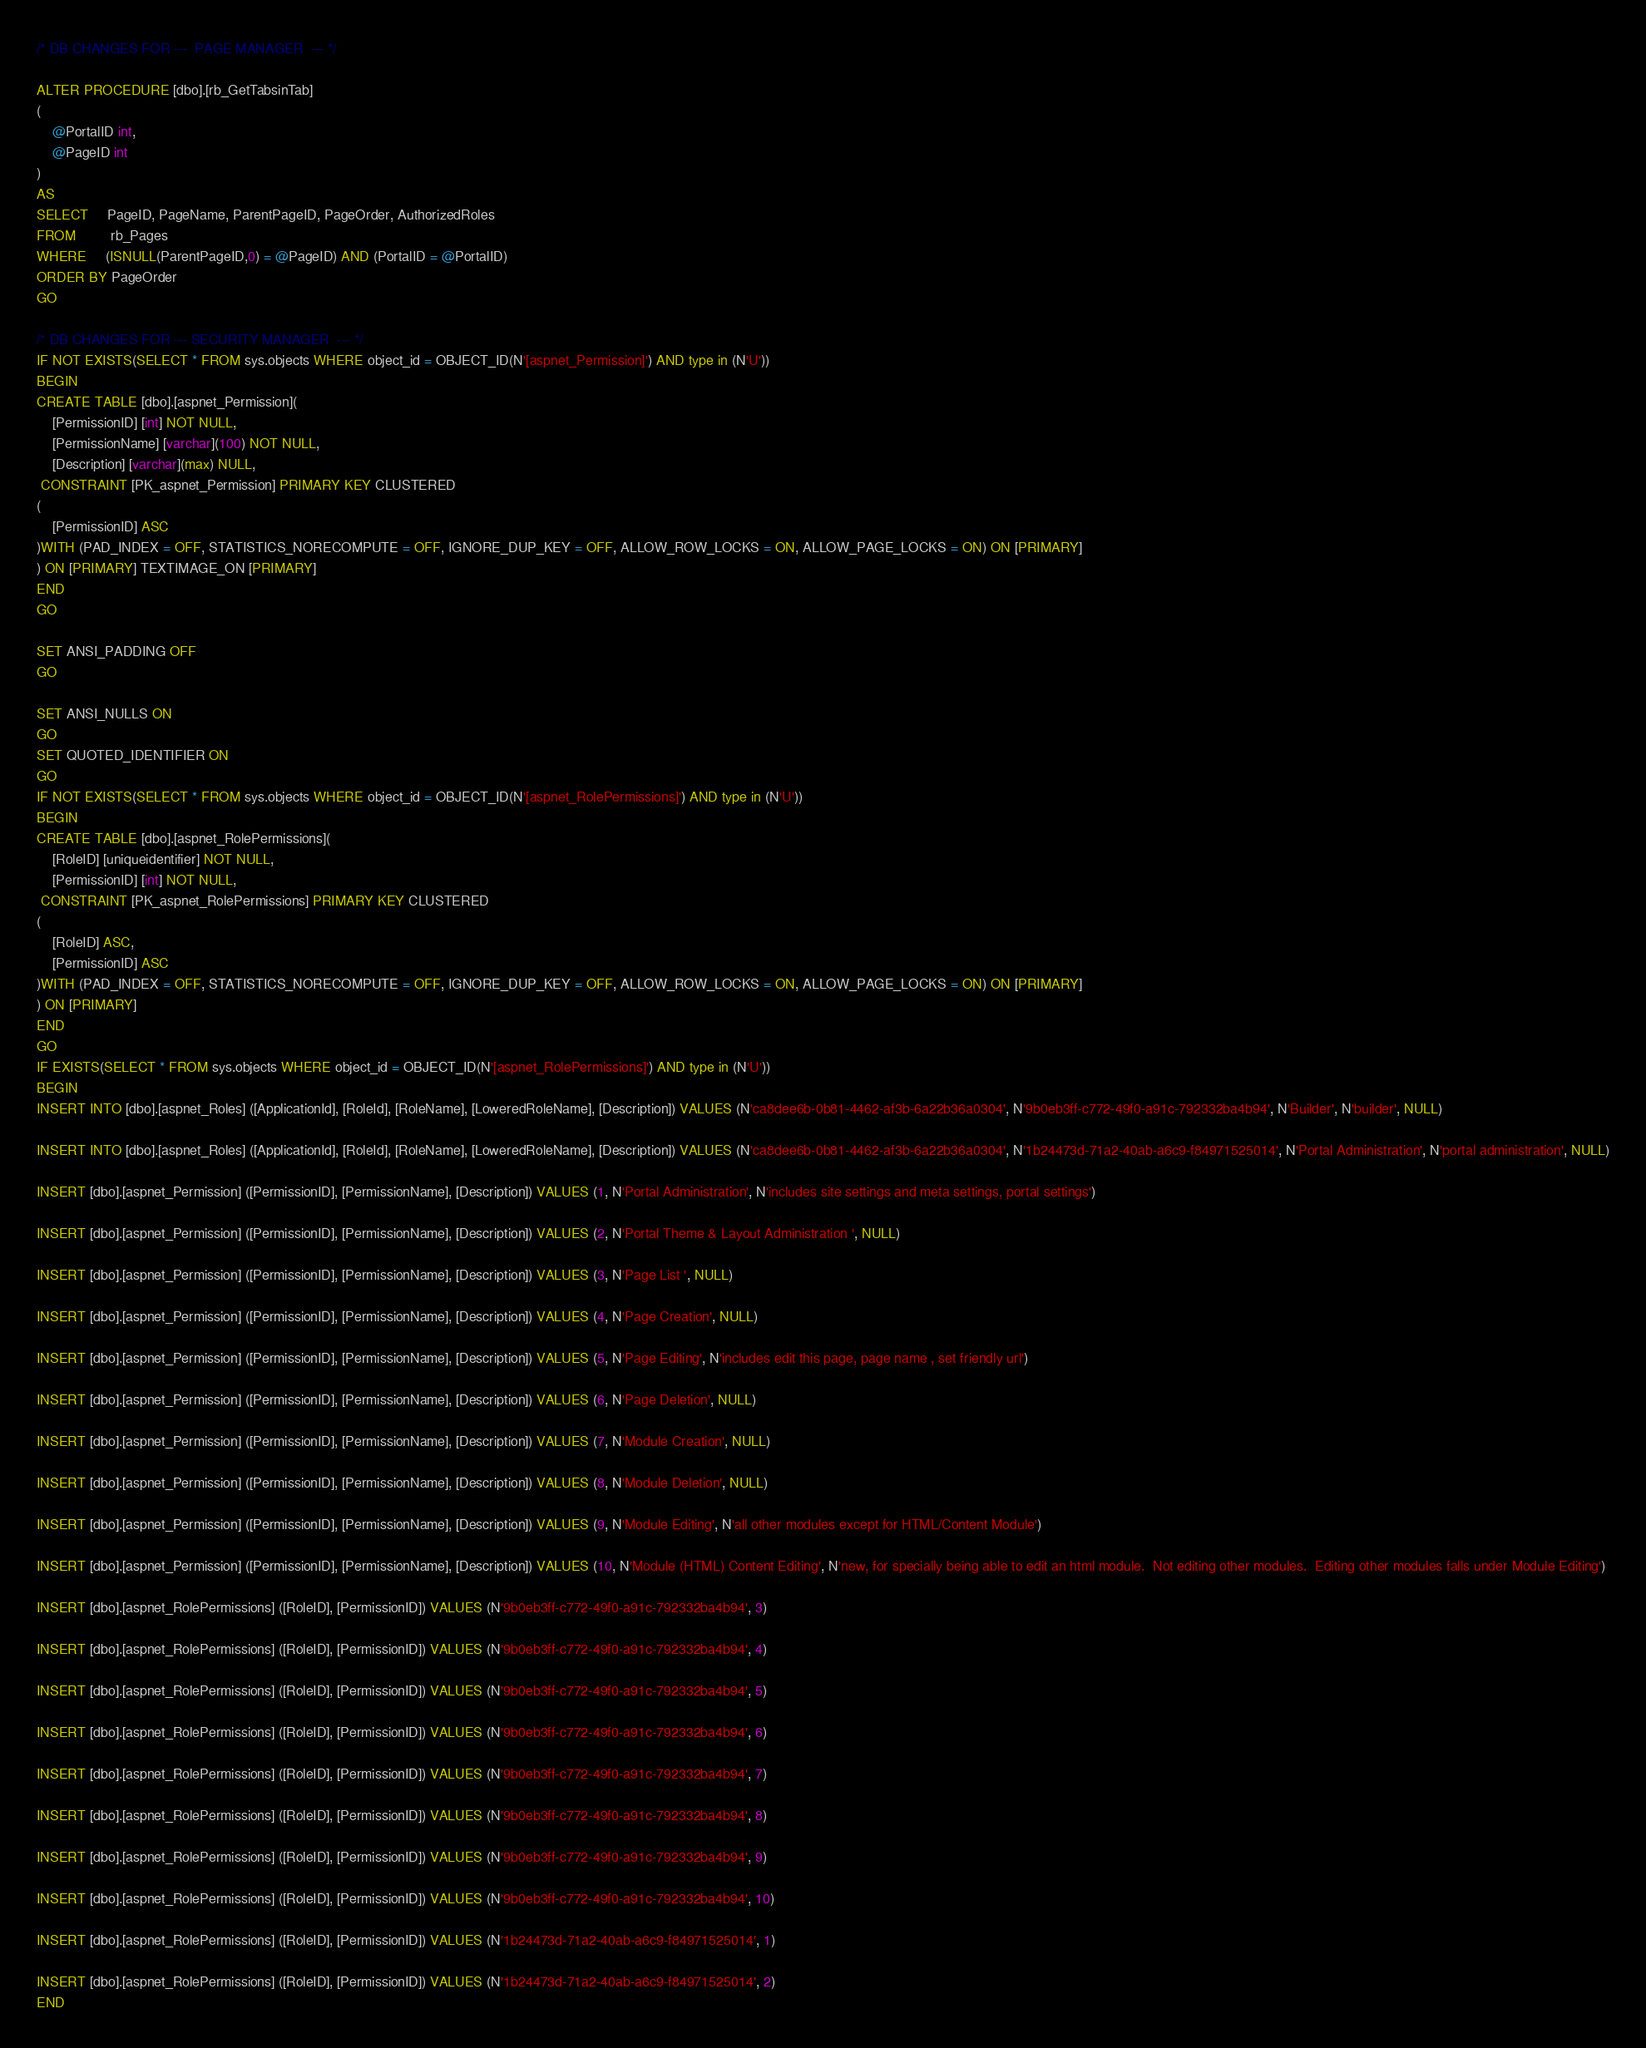Convert code to text. <code><loc_0><loc_0><loc_500><loc_500><_SQL_>/* DB CHANGES FOR ---  PAGE MANAGER  --- */

ALTER PROCEDURE [dbo].[rb_GetTabsinTab]
(
	@PortalID int,
	@PageID int
)
AS
SELECT     PageID, PageName, ParentPageID, PageOrder, AuthorizedRoles
FROM         rb_Pages
WHERE     (ISNULL(ParentPageID,0) = @PageID) AND (PortalID = @PortalID)
ORDER BY PageOrder
GO

/* DB CHANGES FOR --- SECURITY MANAGER  --- */
IF NOT EXISTS(SELECT * FROM sys.objects WHERE object_id = OBJECT_ID(N'[aspnet_Permission]') AND type in (N'U'))
BEGIN
CREATE TABLE [dbo].[aspnet_Permission](
	[PermissionID] [int] NOT NULL,
	[PermissionName] [varchar](100) NOT NULL,
	[Description] [varchar](max) NULL,
 CONSTRAINT [PK_aspnet_Permission] PRIMARY KEY CLUSTERED 
(
	[PermissionID] ASC
)WITH (PAD_INDEX = OFF, STATISTICS_NORECOMPUTE = OFF, IGNORE_DUP_KEY = OFF, ALLOW_ROW_LOCKS = ON, ALLOW_PAGE_LOCKS = ON) ON [PRIMARY]
) ON [PRIMARY] TEXTIMAGE_ON [PRIMARY]
END
GO

SET ANSI_PADDING OFF
GO

SET ANSI_NULLS ON
GO
SET QUOTED_IDENTIFIER ON
GO
IF NOT EXISTS(SELECT * FROM sys.objects WHERE object_id = OBJECT_ID(N'[aspnet_RolePermissions]') AND type in (N'U'))
BEGIN
CREATE TABLE [dbo].[aspnet_RolePermissions](
	[RoleID] [uniqueidentifier] NOT NULL,
	[PermissionID] [int] NOT NULL,
 CONSTRAINT [PK_aspnet_RolePermissions] PRIMARY KEY CLUSTERED 
(
	[RoleID] ASC,
	[PermissionID] ASC
)WITH (PAD_INDEX = OFF, STATISTICS_NORECOMPUTE = OFF, IGNORE_DUP_KEY = OFF, ALLOW_ROW_LOCKS = ON, ALLOW_PAGE_LOCKS = ON) ON [PRIMARY]
) ON [PRIMARY]
END
GO
IF EXISTS(SELECT * FROM sys.objects WHERE object_id = OBJECT_ID(N'[aspnet_RolePermissions]') AND type in (N'U'))
BEGIN
INSERT INTO [dbo].[aspnet_Roles] ([ApplicationId], [RoleId], [RoleName], [LoweredRoleName], [Description]) VALUES (N'ca8dee6b-0b81-4462-af3b-6a22b36a0304', N'9b0eb3ff-c772-49f0-a91c-792332ba4b94', N'Builder', N'builder', NULL)

INSERT INTO [dbo].[aspnet_Roles] ([ApplicationId], [RoleId], [RoleName], [LoweredRoleName], [Description]) VALUES (N'ca8dee6b-0b81-4462-af3b-6a22b36a0304', N'1b24473d-71a2-40ab-a6c9-f84971525014', N'Portal Administration', N'portal administration', NULL)

INSERT [dbo].[aspnet_Permission] ([PermissionID], [PermissionName], [Description]) VALUES (1, N'Portal Administration', N'includes site settings and meta settings, portal settings')

INSERT [dbo].[aspnet_Permission] ([PermissionID], [PermissionName], [Description]) VALUES (2, N'Portal Theme & Layout Administration ', NULL)

INSERT [dbo].[aspnet_Permission] ([PermissionID], [PermissionName], [Description]) VALUES (3, N'Page List ', NULL)

INSERT [dbo].[aspnet_Permission] ([PermissionID], [PermissionName], [Description]) VALUES (4, N'Page Creation', NULL)

INSERT [dbo].[aspnet_Permission] ([PermissionID], [PermissionName], [Description]) VALUES (5, N'Page Editing', N'includes edit this page, page name , set friendly url')

INSERT [dbo].[aspnet_Permission] ([PermissionID], [PermissionName], [Description]) VALUES (6, N'Page Deletion', NULL)

INSERT [dbo].[aspnet_Permission] ([PermissionID], [PermissionName], [Description]) VALUES (7, N'Module Creation', NULL)

INSERT [dbo].[aspnet_Permission] ([PermissionID], [PermissionName], [Description]) VALUES (8, N'Module Deletion', NULL)

INSERT [dbo].[aspnet_Permission] ([PermissionID], [PermissionName], [Description]) VALUES (9, N'Module Editing', N'all other modules except for HTML/Content Module')

INSERT [dbo].[aspnet_Permission] ([PermissionID], [PermissionName], [Description]) VALUES (10, N'Module (HTML) Content Editing', N'new, for specially being able to edit an html module.  Not editing other modules.  Editing other modules falls under Module Editing')

INSERT [dbo].[aspnet_RolePermissions] ([RoleID], [PermissionID]) VALUES (N'9b0eb3ff-c772-49f0-a91c-792332ba4b94', 3)

INSERT [dbo].[aspnet_RolePermissions] ([RoleID], [PermissionID]) VALUES (N'9b0eb3ff-c772-49f0-a91c-792332ba4b94', 4)

INSERT [dbo].[aspnet_RolePermissions] ([RoleID], [PermissionID]) VALUES (N'9b0eb3ff-c772-49f0-a91c-792332ba4b94', 5)

INSERT [dbo].[aspnet_RolePermissions] ([RoleID], [PermissionID]) VALUES (N'9b0eb3ff-c772-49f0-a91c-792332ba4b94', 6)

INSERT [dbo].[aspnet_RolePermissions] ([RoleID], [PermissionID]) VALUES (N'9b0eb3ff-c772-49f0-a91c-792332ba4b94', 7)

INSERT [dbo].[aspnet_RolePermissions] ([RoleID], [PermissionID]) VALUES (N'9b0eb3ff-c772-49f0-a91c-792332ba4b94', 8)

INSERT [dbo].[aspnet_RolePermissions] ([RoleID], [PermissionID]) VALUES (N'9b0eb3ff-c772-49f0-a91c-792332ba4b94', 9)

INSERT [dbo].[aspnet_RolePermissions] ([RoleID], [PermissionID]) VALUES (N'9b0eb3ff-c772-49f0-a91c-792332ba4b94', 10)

INSERT [dbo].[aspnet_RolePermissions] ([RoleID], [PermissionID]) VALUES (N'1b24473d-71a2-40ab-a6c9-f84971525014', 1)

INSERT [dbo].[aspnet_RolePermissions] ([RoleID], [PermissionID]) VALUES (N'1b24473d-71a2-40ab-a6c9-f84971525014', 2)
END</code> 